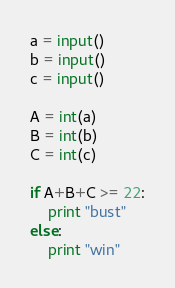<code> <loc_0><loc_0><loc_500><loc_500><_Python_>a = input()
b = input()
c = input()
 
A = int(a)
B = int(b)
C = int(c)
  
if A+B+C >= 22:
	print "bust"
else:
	print "win"</code> 